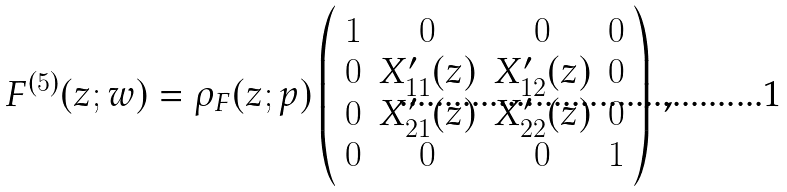Convert formula to latex. <formula><loc_0><loc_0><loc_500><loc_500>F ^ { ( 5 ) } ( z ; w ) = \rho _ { F } ( z ; p ) \left ( \begin{array} { c c c c } 1 & 0 & 0 & 0 \\ 0 & X _ { 1 1 } ^ { \prime } ( z ) & X _ { 1 2 } ^ { \prime } ( z ) & 0 \\ 0 & X _ { 2 1 } ^ { \prime } ( z ) & X _ { 2 2 } ^ { \prime } ( z ) & 0 \\ 0 & 0 & 0 & 1 \\ \end{array} \right ) \, ,</formula> 